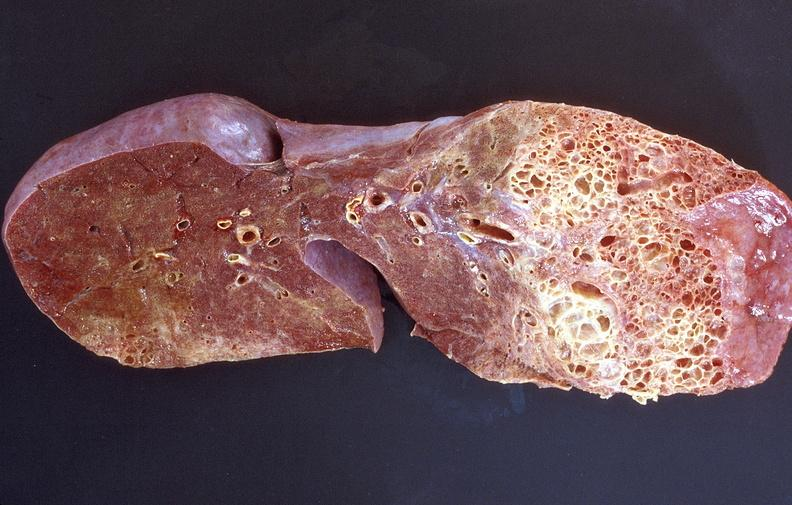where is this?
Answer the question using a single word or phrase. Lung 